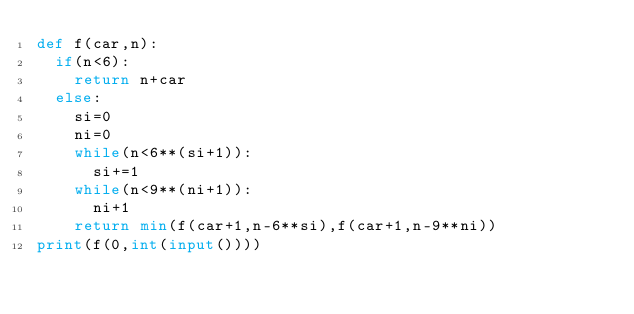<code> <loc_0><loc_0><loc_500><loc_500><_Python_>def f(car,n):
  if(n<6):
    return n+car
  else:
    si=0
    ni=0
    while(n<6**(si+1)):
      si+=1
    while(n<9**(ni+1)):
      ni+1
    return min(f(car+1,n-6**si),f(car+1,n-9**ni))
print(f(0,int(input())))</code> 